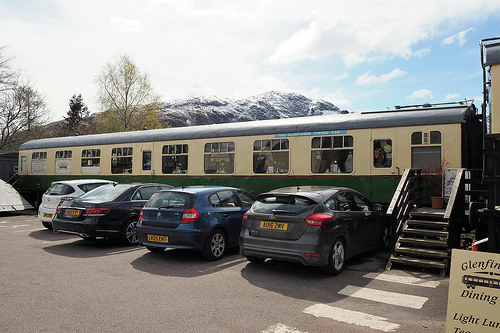<image>
Can you confirm if the car is in front of the train? Yes. The car is positioned in front of the train, appearing closer to the camera viewpoint. 